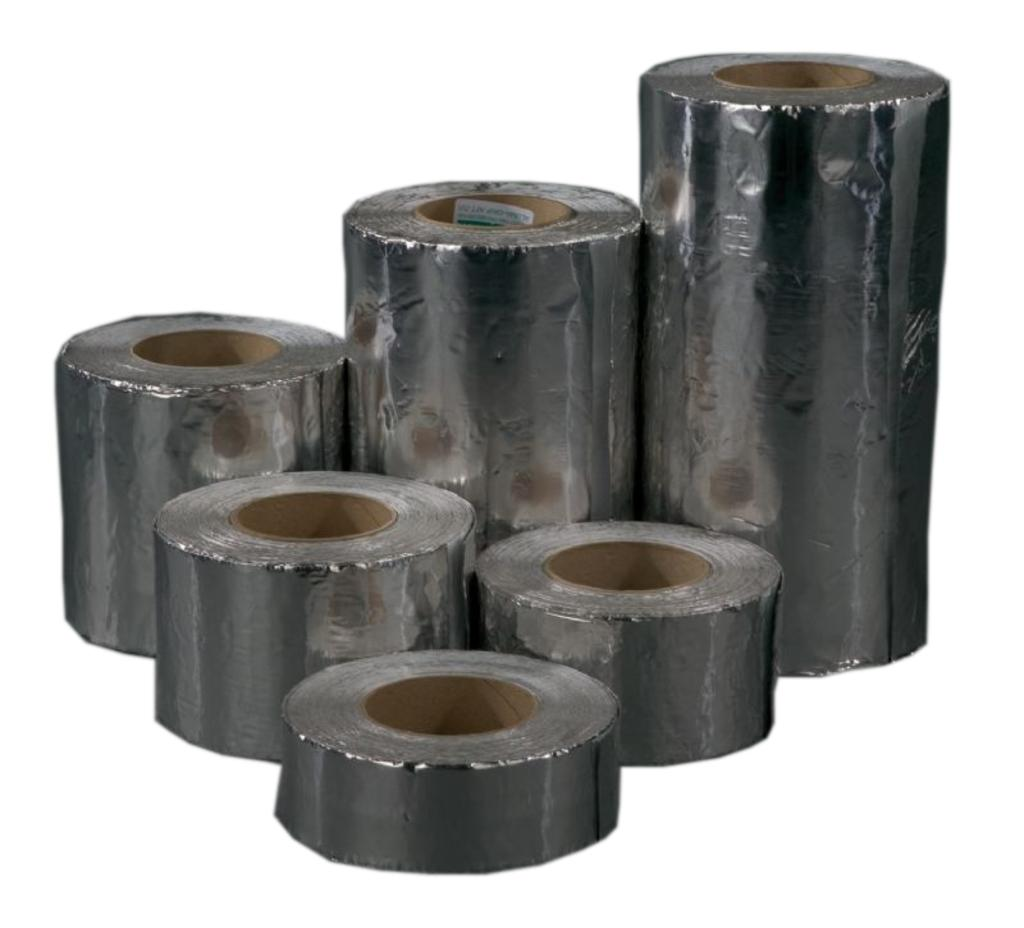What objects can be seen in the image? There are plasters in the image. What color is the background of the image? The background of the image is white. How many twigs are visible in the image? There are no twigs present in the image. What type of stamp can be seen on the plasters in the image? There are no stamps visible on the plasters in the image. 